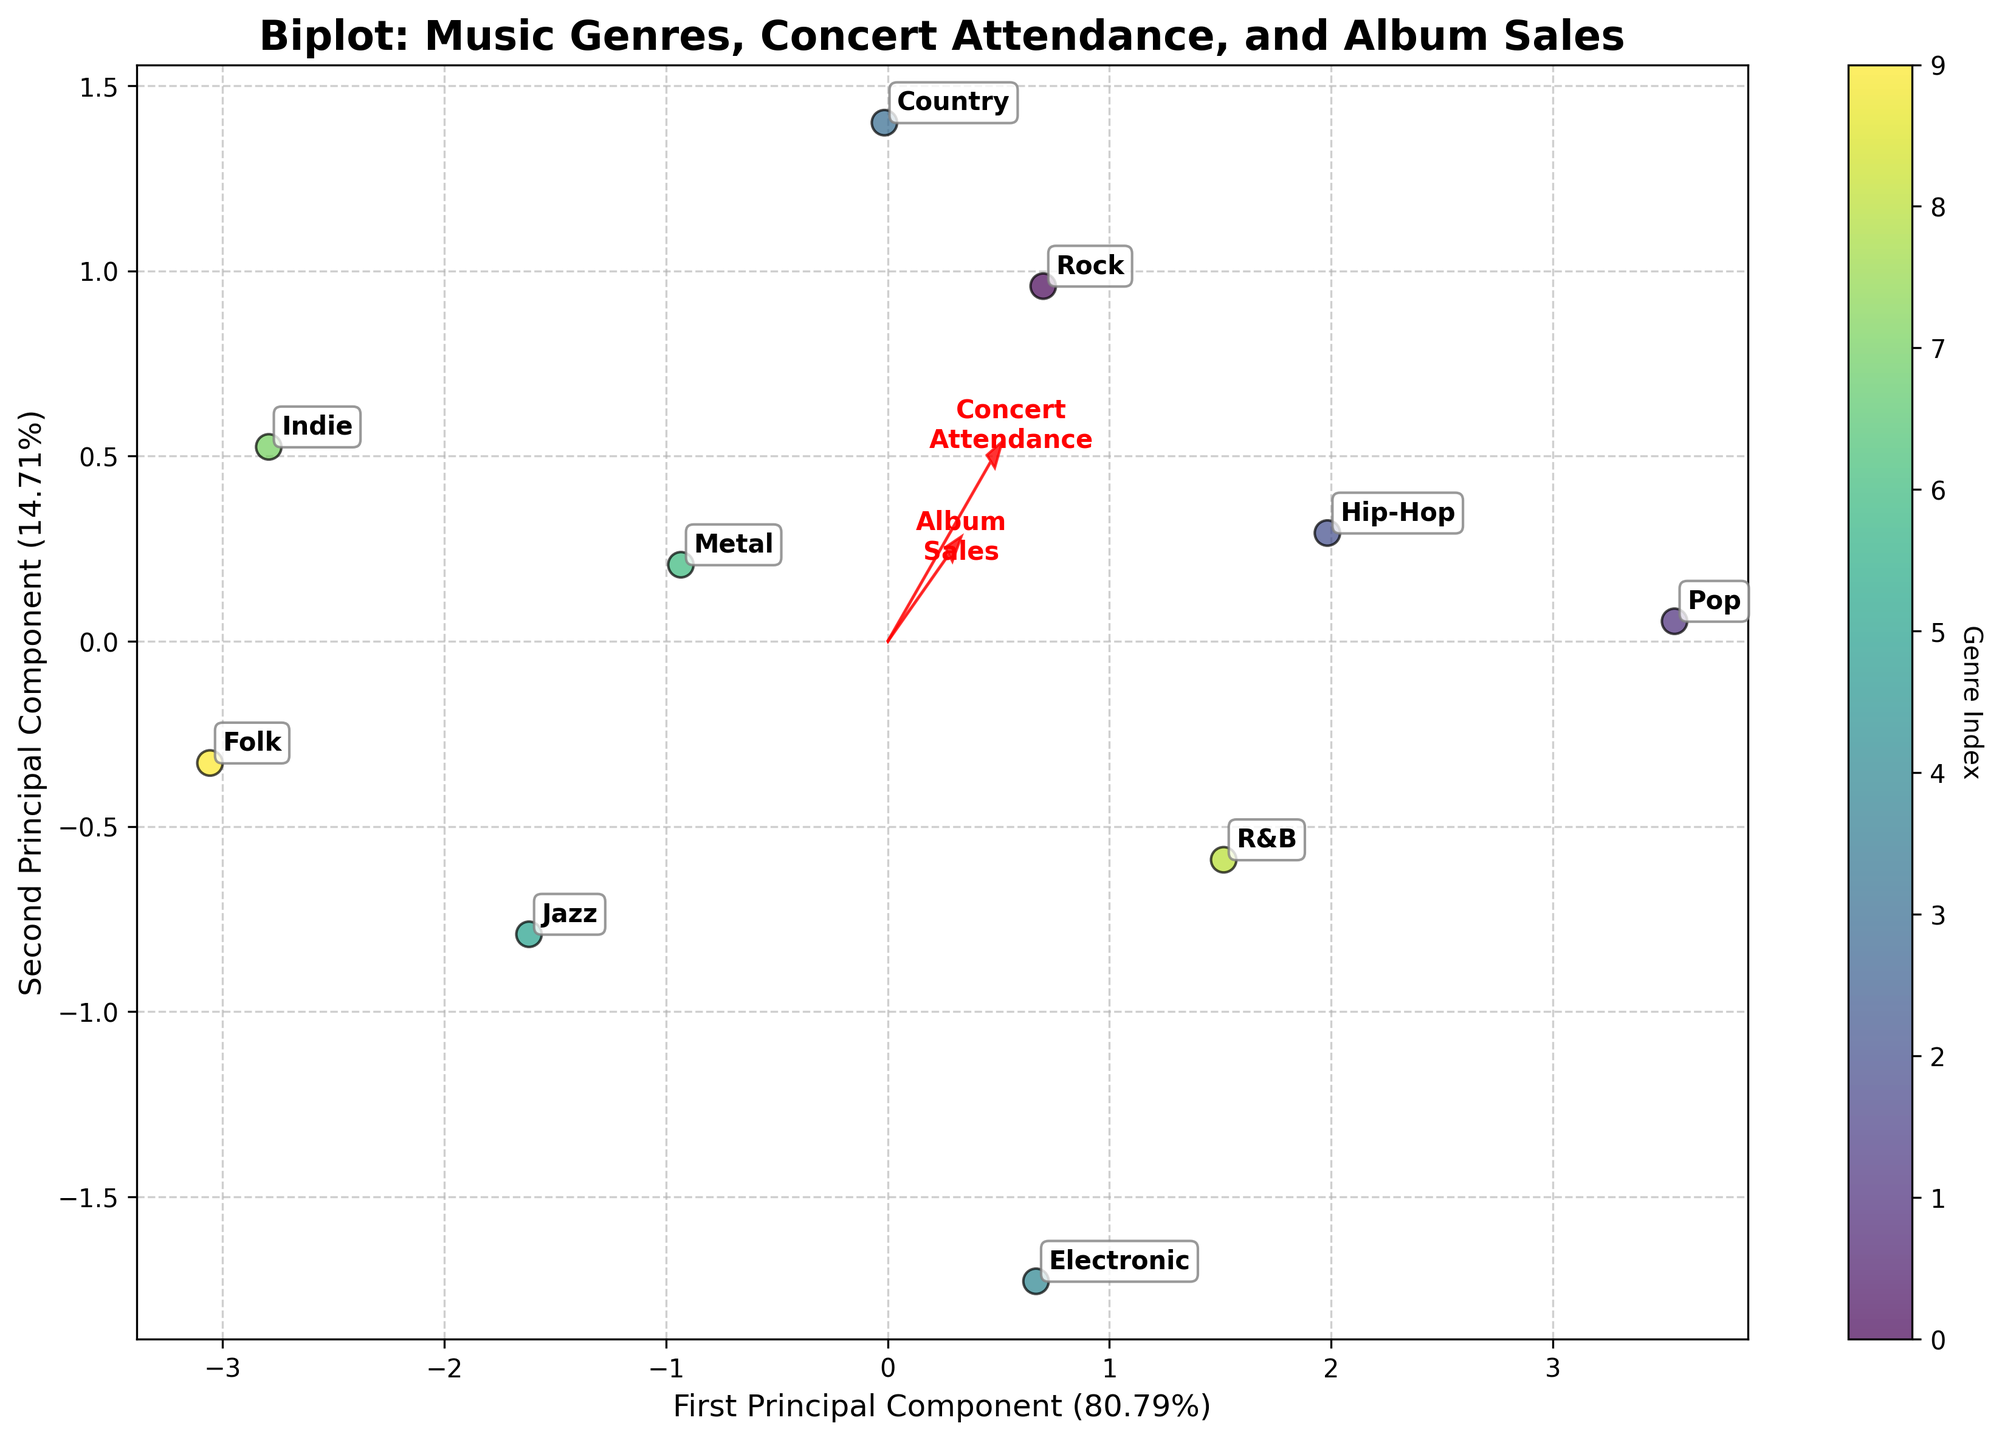How many music genres are depicted in the plot? Count the number of distinct labeled data points on the plot. Each label represents a different genre.
Answer: 10 What does the first principal component represent? The first principal component is labeled on the x-axis with a percentage explaining its importance.
Answer: Concert Attendance Which genre has the highest album sales in the plot? Look for the genre that is closest to the tip of the arrow labeled 'Album Sales'.
Answer: Pop Between Rock and Jazz, which genre has higher concert attendance? Locate the labels for Rock and Jazz, then compare their positions relative to the 'Concert Attendance' vector.
Answer: Rock Which factor influences Indie and Folk genres more, Artist Preference or Media Exposure? Check the positioning of Indie and Folk labels relative to the 'Artist Preference' and 'Media Exposure' vectors.
Answer: Artist Preference Based on the vectors, which features positively correlate the most? Compare the directions of feature vectors to identify which ones are aligned similarly, indicating positive correlation.
Answer: Concert Attendance and Album Sales How do Hip-Hop and Country genres compare in fan engagement? Locate the positions of Hip-Hop and Country, then relate their positions to the 'Fan Engagement' vector.
Answer: Hip-Hop is higher Does Media Exposure have a strong impact on Rock and Metal genres? Examine how close the Rock and Metal labels are to the 'Media Exposure' vector.
Answer: No Which genre has the smallest media exposure? Find the genre label that is farthest away from the 'Media Exposure' vector.
Answer: Folk What principal component explains more variance in the data? Compare the percentages of variance explained by the first and second principal components as indicated on their respective axes.
Answer: First Principal Component 